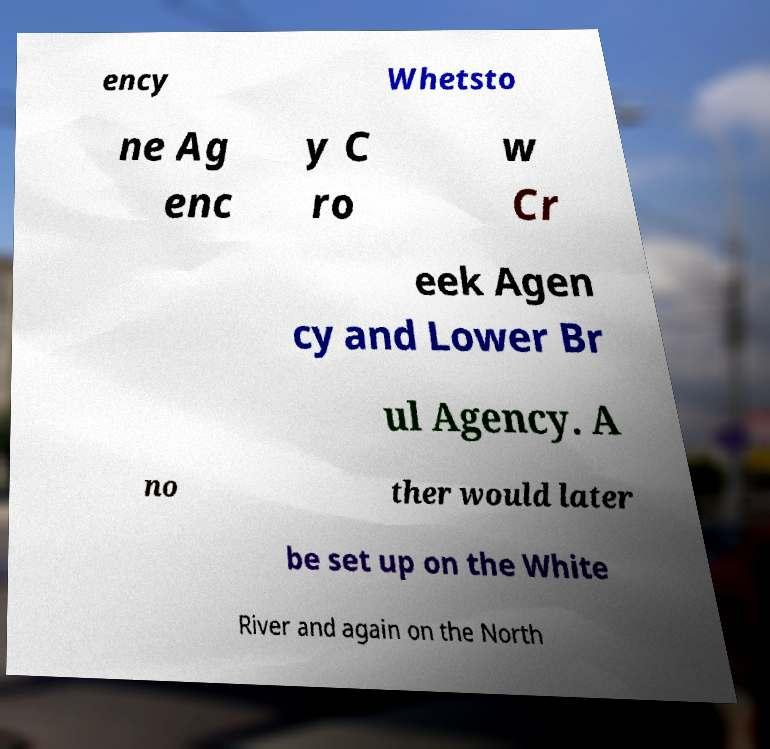Could you extract and type out the text from this image? ency Whetsto ne Ag enc y C ro w Cr eek Agen cy and Lower Br ul Agency. A no ther would later be set up on the White River and again on the North 